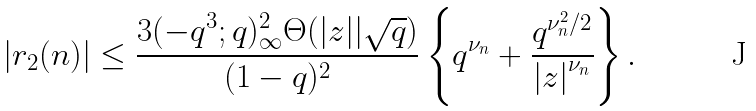<formula> <loc_0><loc_0><loc_500><loc_500>| r _ { 2 } ( n ) | \leq \frac { 3 ( - q ^ { 3 } ; q ) _ { \infty } ^ { 2 } \Theta ( | z | | \sqrt { q } ) } { ( 1 - q ) ^ { 2 } } \left \{ q ^ { \nu _ { n } } + \frac { q ^ { \nu _ { n } ^ { 2 } / 2 } } { { | z | } ^ { \nu _ { n } } } \right \} .</formula> 